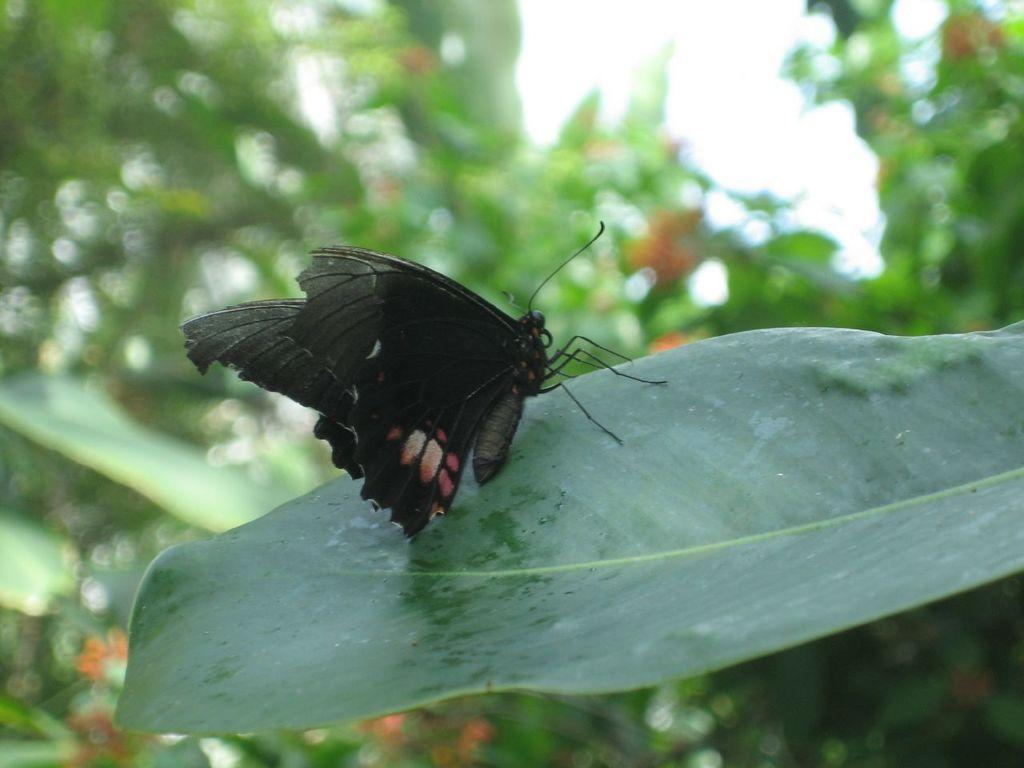What is on the leaf in the image? There is a butterfly on a leaf in the image. What can be seen in the background of the image? There are trees and the sky visible in the background of the image. What type of roof can be seen on the butterfly in the image? There is no roof present in the image, as it features a butterfly on a leaf. 